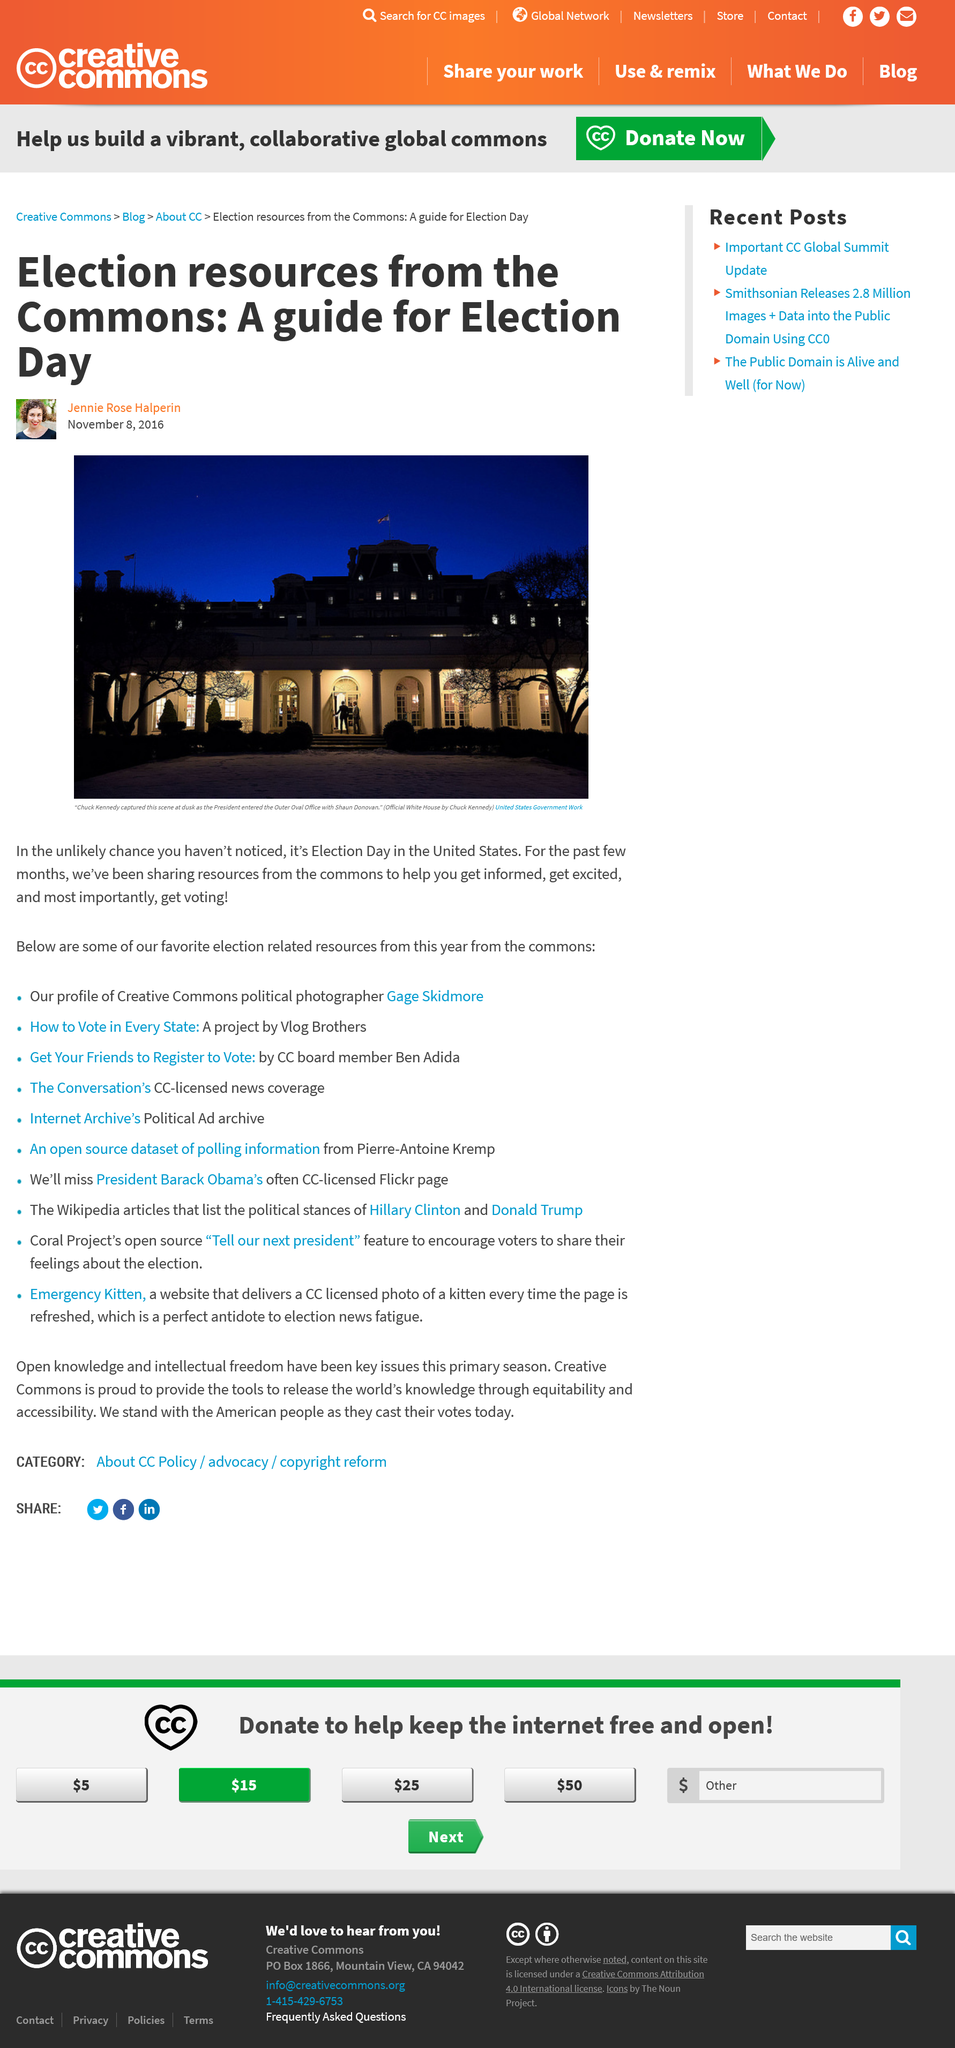Point out several critical features in this image. The article is covering the event of Election Day. The President is depicted in a photograph with Shaun Donovan. The author of the article "Election resources from the Commons: A guide for Election day" is Jennie Rose Halperin. 